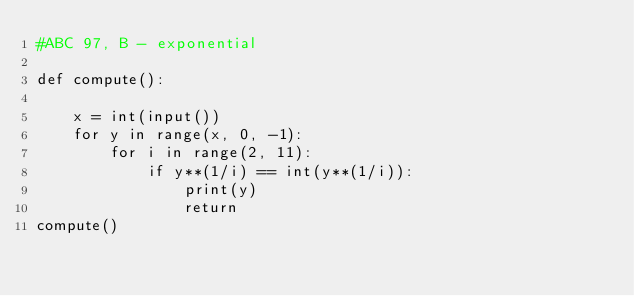Convert code to text. <code><loc_0><loc_0><loc_500><loc_500><_Python_>#ABC 97, B - exponential

def compute():

    x = int(input())
    for y in range(x, 0, -1):
        for i in range(2, 11):
            if y**(1/i) == int(y**(1/i)):
                print(y)
                return
compute()
</code> 